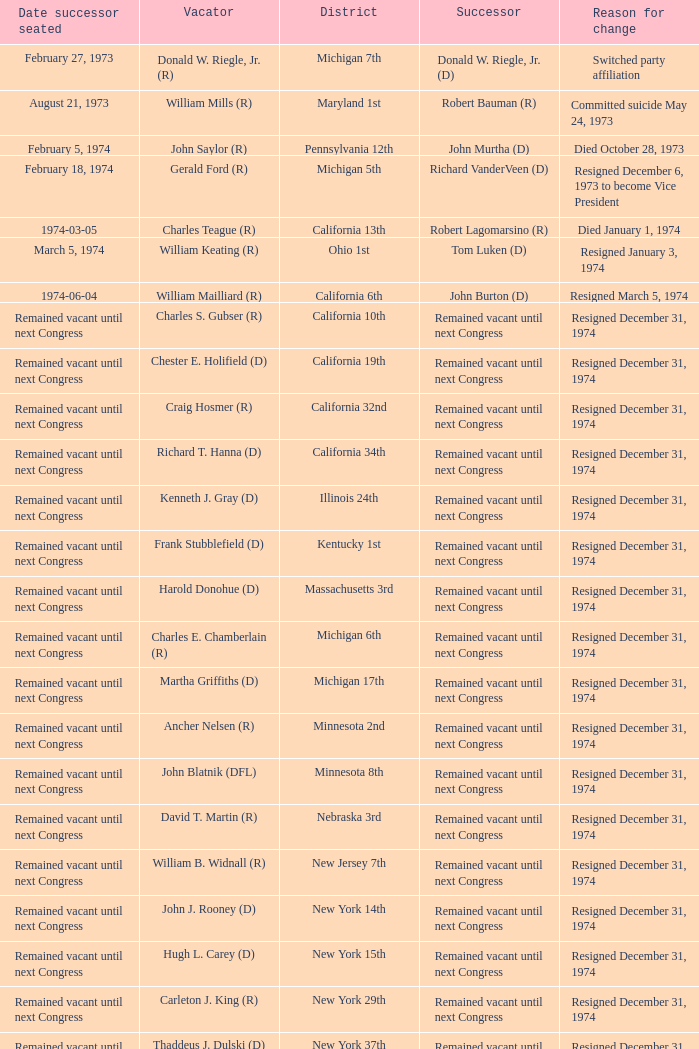Who was the successor when the vacator was chester e. holifield (d)? Remained vacant until next Congress. 